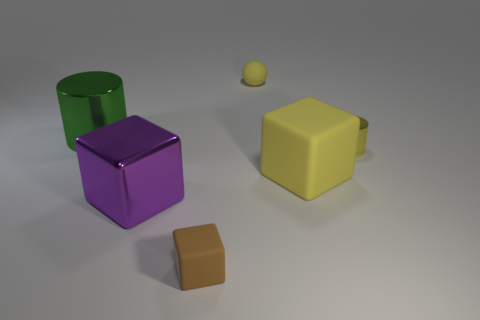Subtract all big blocks. How many blocks are left? 1 Add 1 large cyan objects. How many objects exist? 7 Subtract all yellow cylinders. How many cylinders are left? 1 Subtract all cylinders. How many objects are left? 4 Add 4 big rubber objects. How many big rubber objects are left? 5 Add 3 big yellow cubes. How many big yellow cubes exist? 4 Subtract 0 red balls. How many objects are left? 6 Subtract 1 spheres. How many spheres are left? 0 Subtract all purple cylinders. Subtract all red blocks. How many cylinders are left? 2 Subtract all small rubber things. Subtract all small brown matte cubes. How many objects are left? 3 